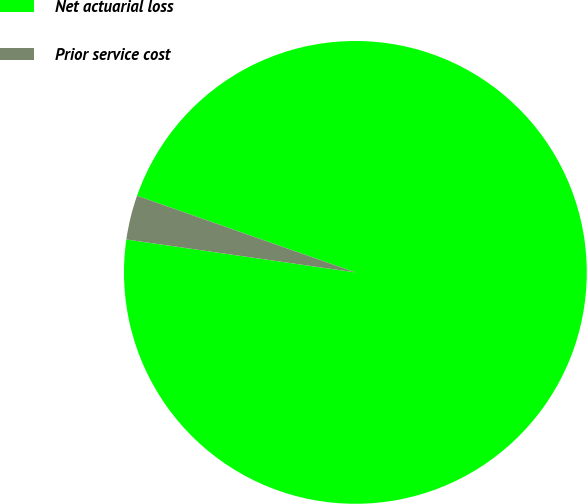Convert chart. <chart><loc_0><loc_0><loc_500><loc_500><pie_chart><fcel>Net actuarial loss<fcel>Prior service cost<nl><fcel>96.9%<fcel>3.1%<nl></chart> 